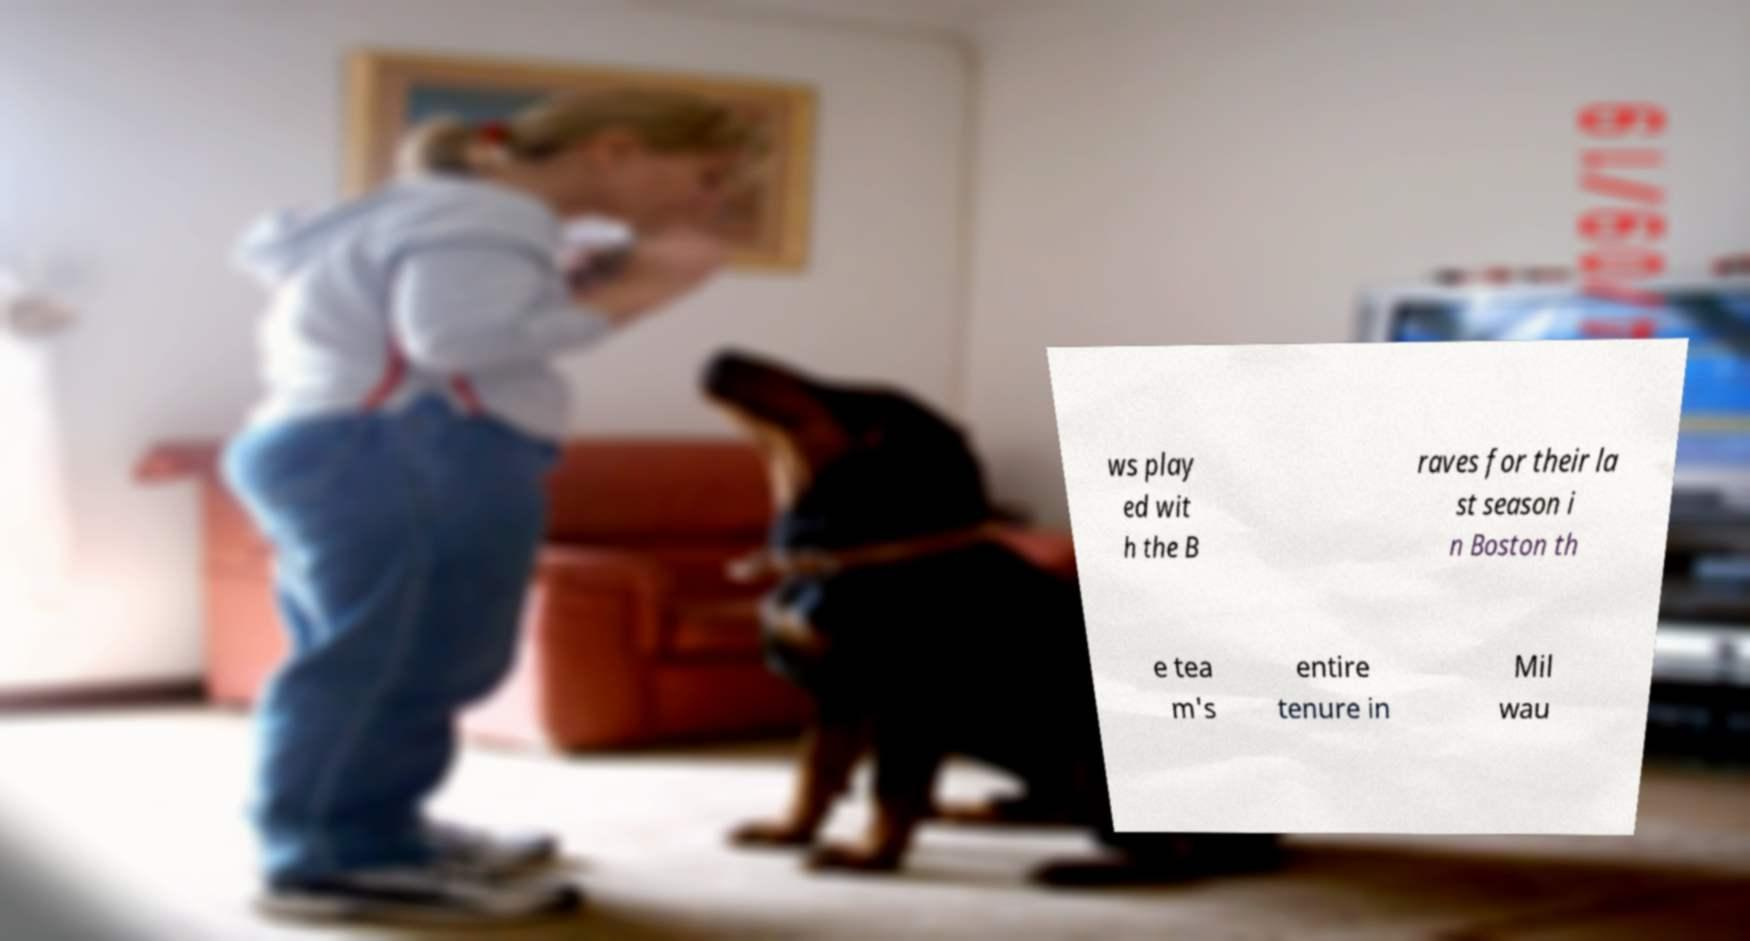Could you assist in decoding the text presented in this image and type it out clearly? ws play ed wit h the B raves for their la st season i n Boston th e tea m's entire tenure in Mil wau 